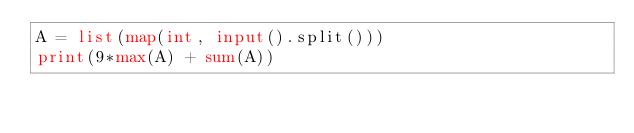<code> <loc_0><loc_0><loc_500><loc_500><_Python_>A = list(map(int, input().split()))
print(9*max(A) + sum(A))</code> 